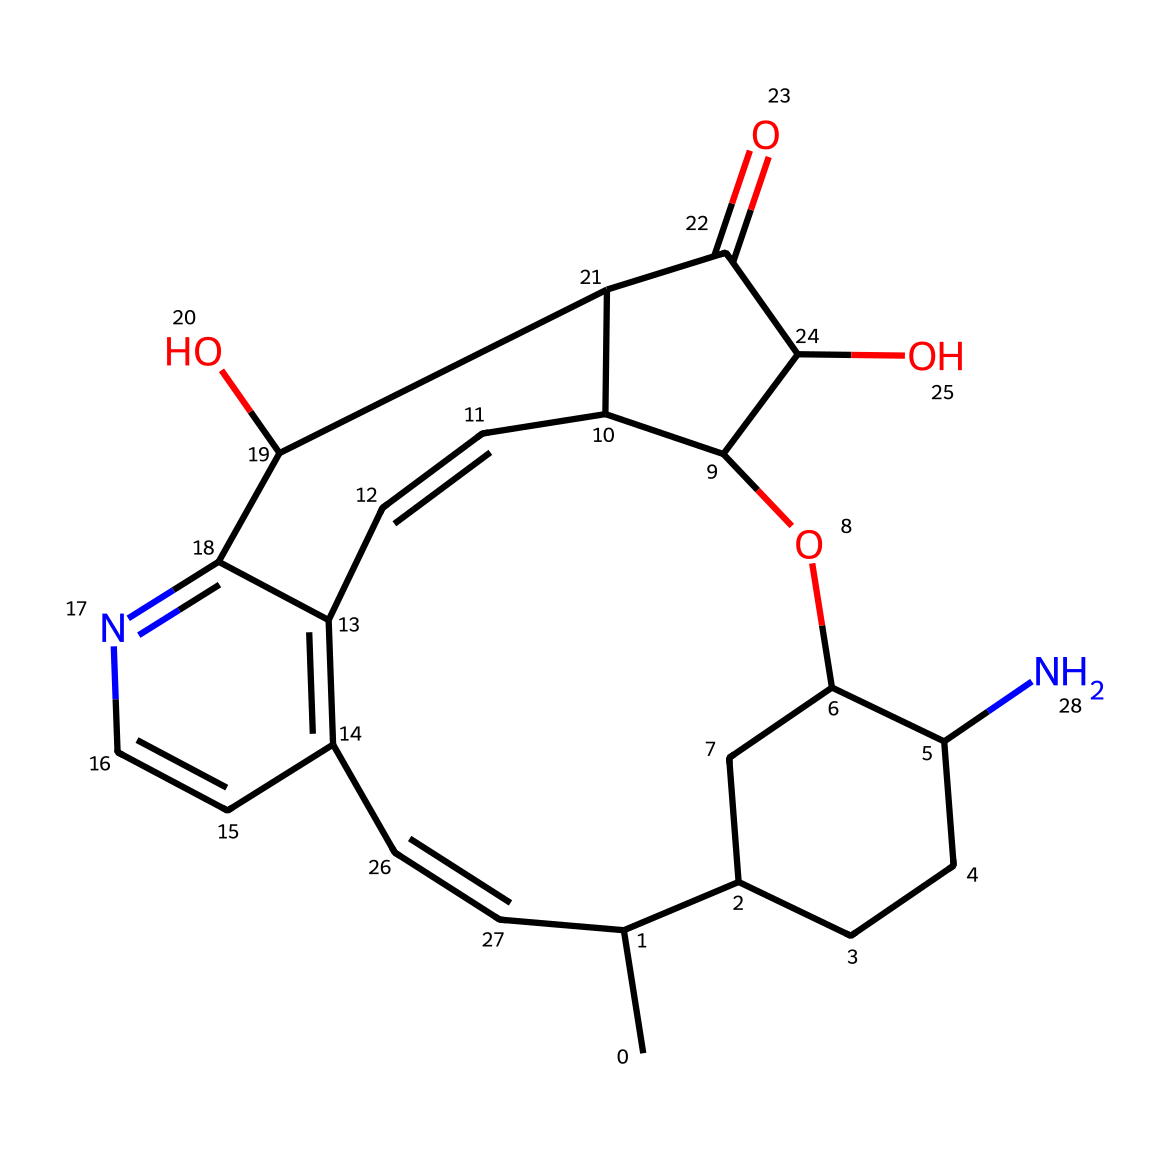What is the primary functional group present in quinine? The structure contains a nitrogen atom, indicating that it includes an amine functional group, which is characteristic of alkaloids.
Answer: amine How many rings are present in the structure of quinine? By inspecting the SMILES representation, there are several cyclic structures identified, totaling three distinct rings in the overall framework.
Answer: three What is the molecular formula for quinine, inferred from the structure? The SMILES format can be decoded to find the number of carbon, hydrogen, nitrogen, and oxygen atoms, leading to a molecular formula of C20H24N2O2.
Answer: C20H24N2O2 Does quinine contain any hydroxyl groups? The presence of -OH (hydroxyl) groups can be identified in SMILES, confirming that there are two such groups attached in the compound.
Answer: yes What type of compound is quinine classified as? The distinctive features of its nitrogen-containing structure and its derivation from plants classify quinine as an alkaloid.
Answer: alkaloid Which element contributes to the bitter taste of quinine? The nitrogen atom in the amine group is known to contribute to the bitter taste characteristic of many alkaloids, including quinine.
Answer: nitrogen 